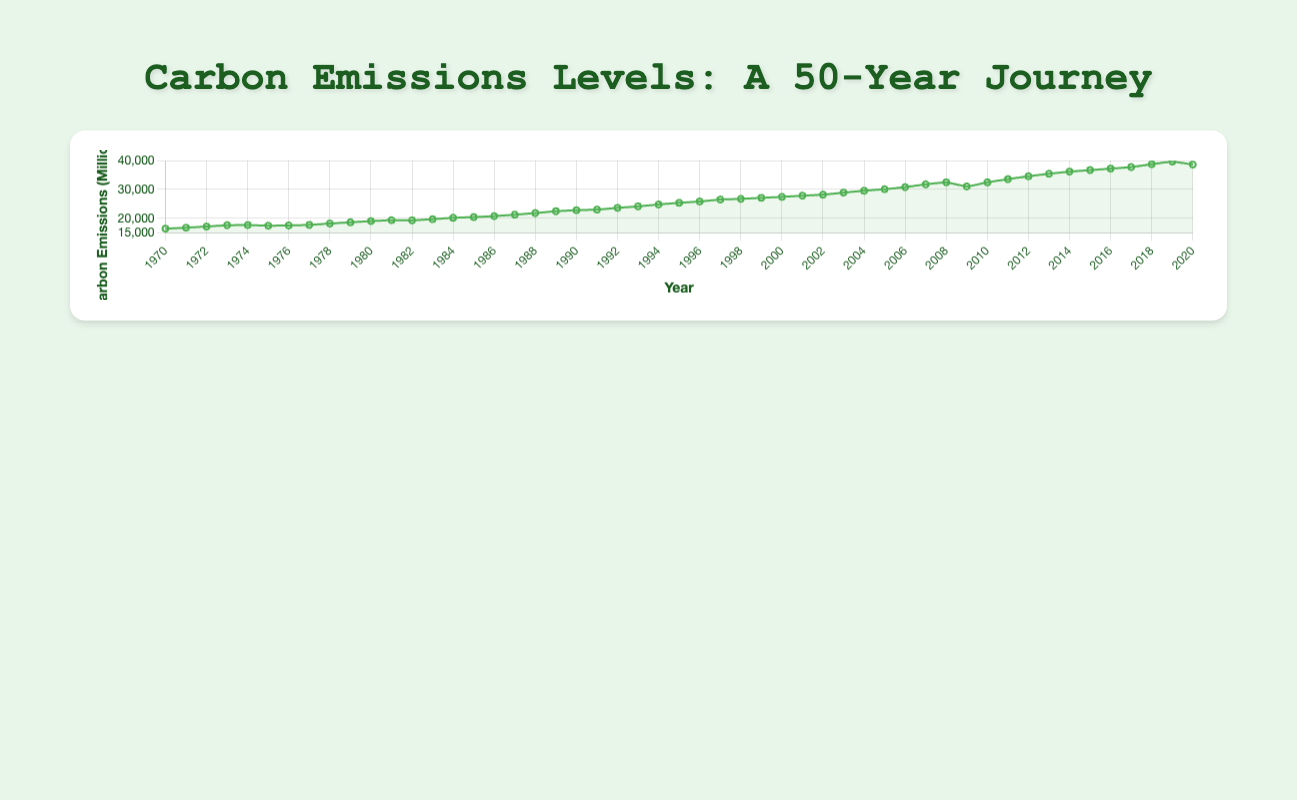which year had the highest carbon emissions? By looking at the chart, we can find the peak point on the y-axis for the carbon emissions data. The year at this point corresponds to the highest emissions. In this chart, the peak carbon emission value is around 2019.
Answer: 2019 How did the carbon emissions trend change after the Clean Air Act in 1970 until 1975? By locating 1970 on the x-axis and observing the trend right after 1970 until 1975, we can see whether the line is increasing, decreasing, or remaining steady. The trend shows a slight increase in emissions from 1970 to 1975.
Answer: Slight Increase Compare the carbon emissions levels in the years 1987 and 1992. We need to locate 1987 and 1992 on the x-axis and compare their corresponding y-values (carbon emissions levels). The emission level in 1987 was around 21240 MT, and for 1992 it was approximately 23600 MT. 1992 has higher emissions.
Answer: 1992 had higher emissions What is the average carbon emission level in the decade of the 2000s (2000-2009)? Sum the carbon emissions levels from 2000 to 2009 and then divide by the number of years (10). The values are 27430, 27840, 28210, 28900, 29570, 30100, 30820, 31790, 32480, 31050. Sum = 268190. Average = 268190 / 10.
Answer: 26819 MT What significant trend change is noticeable during the COVID-19 pandemic year 2020? Identify 2020 on the x-axis and observe its carbon emissions level compared to the previous year, 2019. There is a noticeable drop in emissions from 2019 to 2020.
Answer: Noticeable drop Identify the period where the emissions increased the fastest and state the policy highlights around those periods. Compare the slope of the line in different periods. The steepest increase is seen between 2005 and 2007. The policy highlight during this period is the EU Emission Trading Scheme in 2005.
Answer: 2005-2007, EU Emission Trading Scheme What were the effects of the Great Recession in 2008 on carbon emissions levels? Find 2008 on the x-axis and compare its carbon emission value to adjacent years. In 2008, there’s a decline from 2007 (from 31790 MT to 31050 MT) which continues to 2010 with a slight increase in 2009.
Answer: Decline in 2008 How does the trend between 1970 and 1980 compare visually to the trend between 2010 and 2020? Observe the slopes of the line between 1970-1980 and 2010-2020. Between 1970-1980, the trend is generally increasing, whereas between 2010-2020, the line first increases rapidly then drops due to COVID-19 in 2020.
Answer: 1970-1980: Increasing; 2010-2020: Increasing then sudden drop Calculate the difference in carbon emissions levels between the highest peak year and the year of the Paris Agreement (2015). Find the emissions for the peak year (2019) and 2015. Peak (2019) = 39680 MT, 2015 = 36740 MT. Difference = 39680 - 36740 = 2940 MT
Answer: 2940 MT 